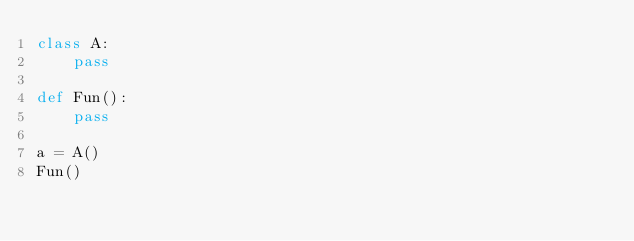<code> <loc_0><loc_0><loc_500><loc_500><_Python_>class A:
	pass

def Fun():
	pass

a = A()
Fun()
</code> 